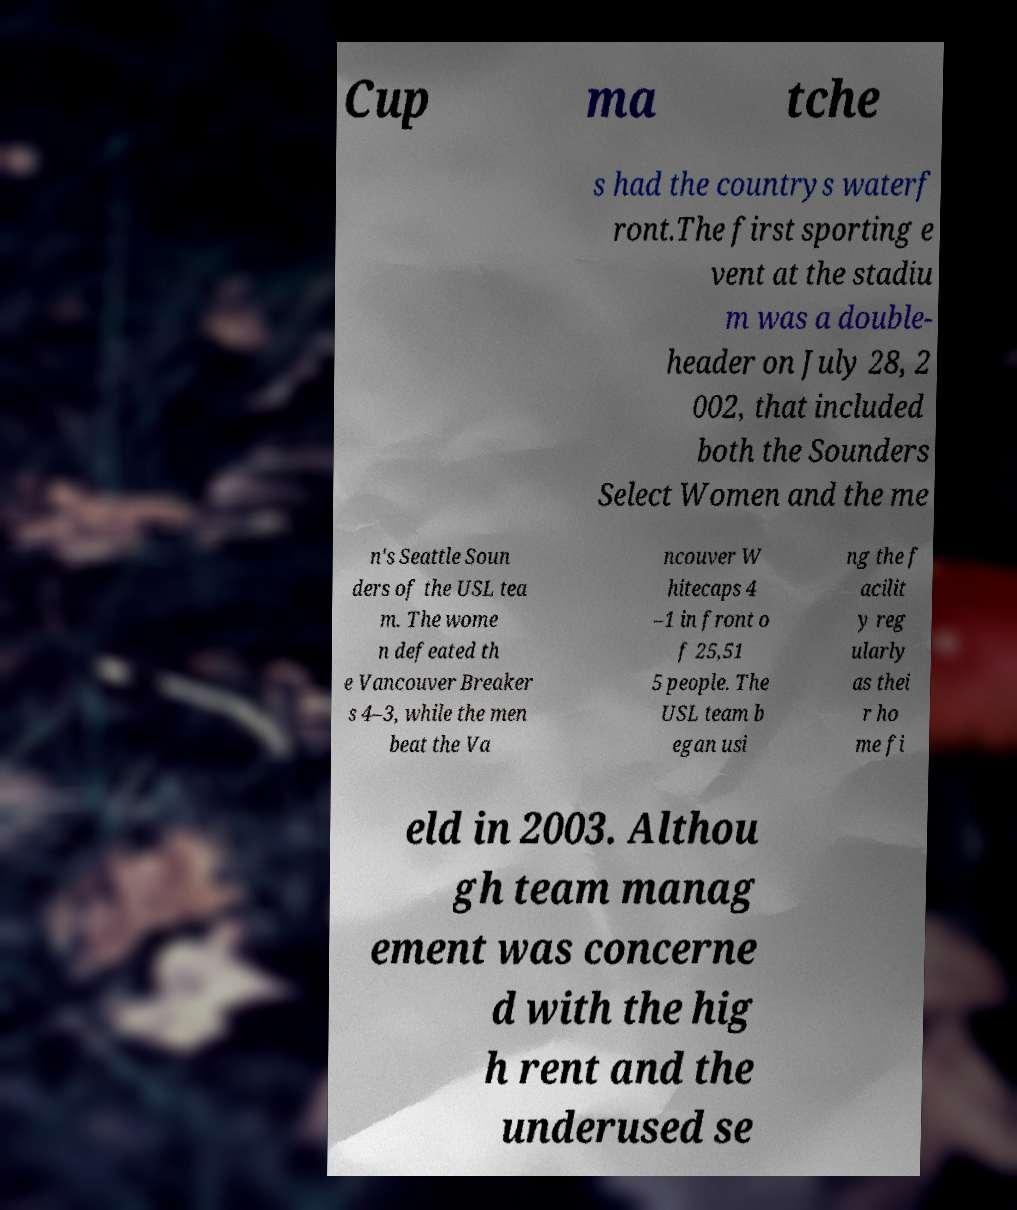Please read and relay the text visible in this image. What does it say? Cup ma tche s had the countrys waterf ront.The first sporting e vent at the stadiu m was a double- header on July 28, 2 002, that included both the Sounders Select Women and the me n's Seattle Soun ders of the USL tea m. The wome n defeated th e Vancouver Breaker s 4–3, while the men beat the Va ncouver W hitecaps 4 –1 in front o f 25,51 5 people. The USL team b egan usi ng the f acilit y reg ularly as thei r ho me fi eld in 2003. Althou gh team manag ement was concerne d with the hig h rent and the underused se 